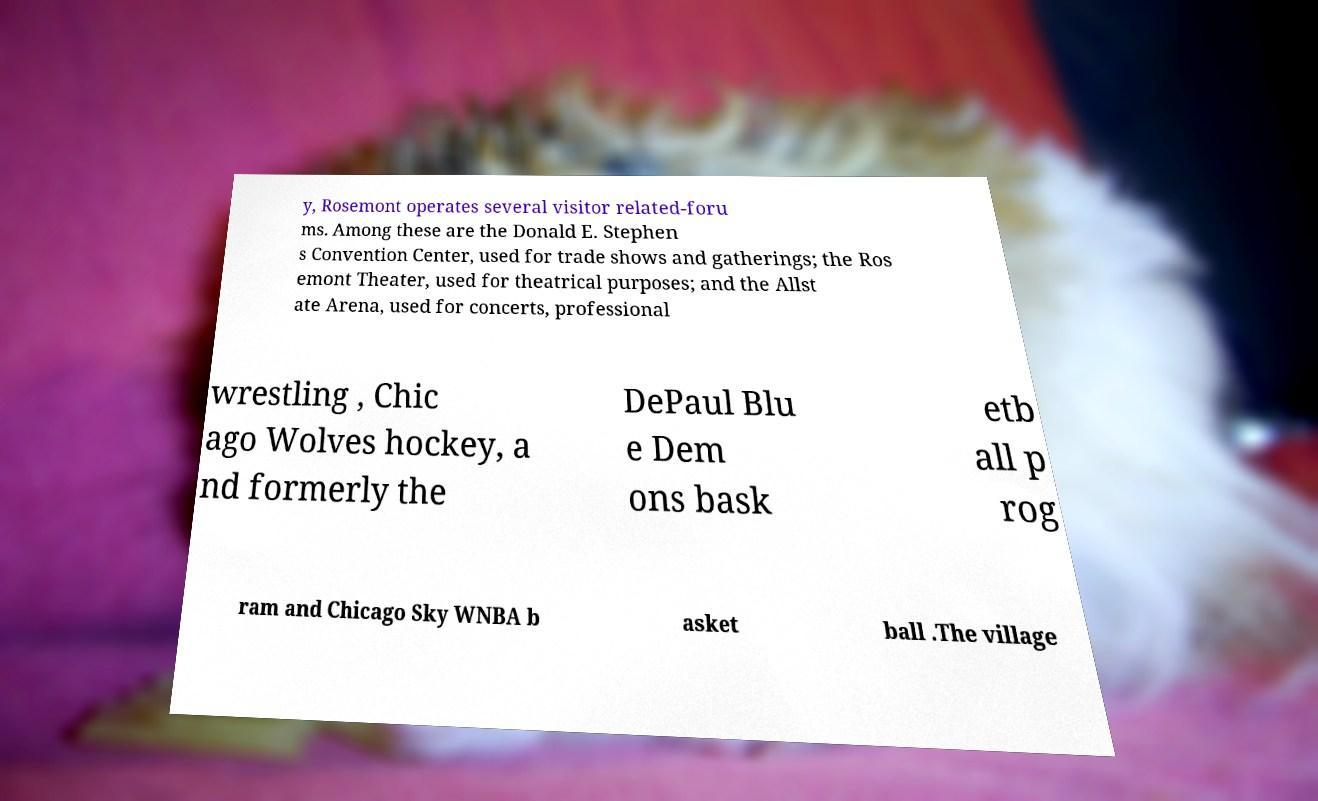Please identify and transcribe the text found in this image. y, Rosemont operates several visitor related-foru ms. Among these are the Donald E. Stephen s Convention Center, used for trade shows and gatherings; the Ros emont Theater, used for theatrical purposes; and the Allst ate Arena, used for concerts, professional wrestling , Chic ago Wolves hockey, a nd formerly the DePaul Blu e Dem ons bask etb all p rog ram and Chicago Sky WNBA b asket ball .The village 